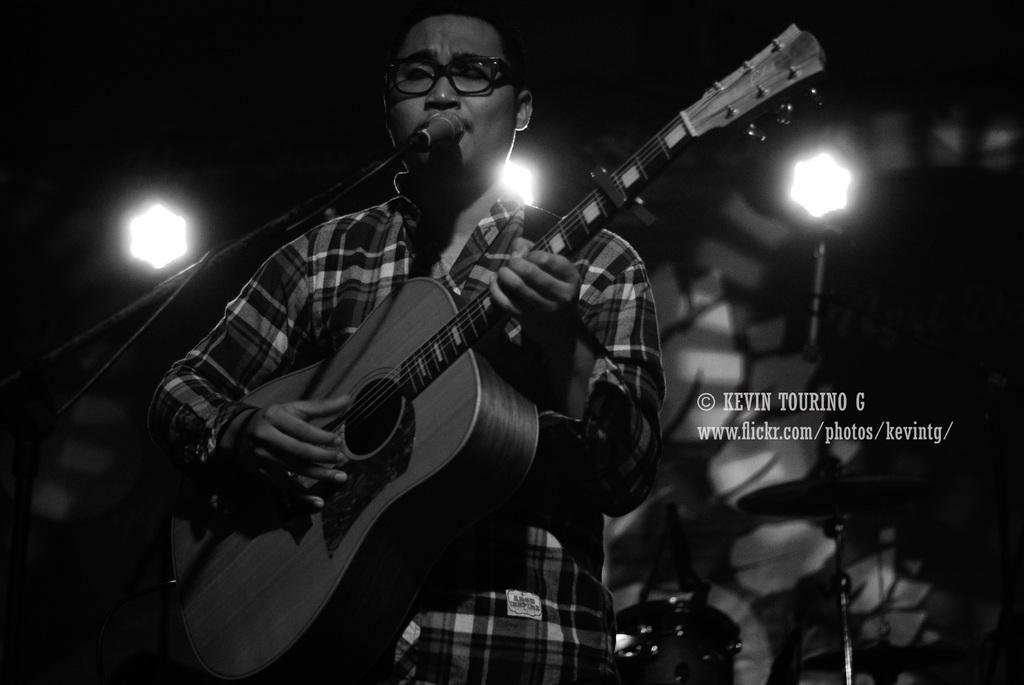What is the man in the image doing? The man is standing, playing a guitar, and singing. What can be seen on the man's face? The man is wearing glasses and has his eyes closed. What is visible in the background of the image? There are 2 lights and musical instruments in the background. What type of letter is the man holding in the image? There is no letter present in the image; the man is playing a guitar and singing. How many trucks can be seen in the background of the image? There are no trucks visible in the image; only lights and musical instruments are present in the background. 